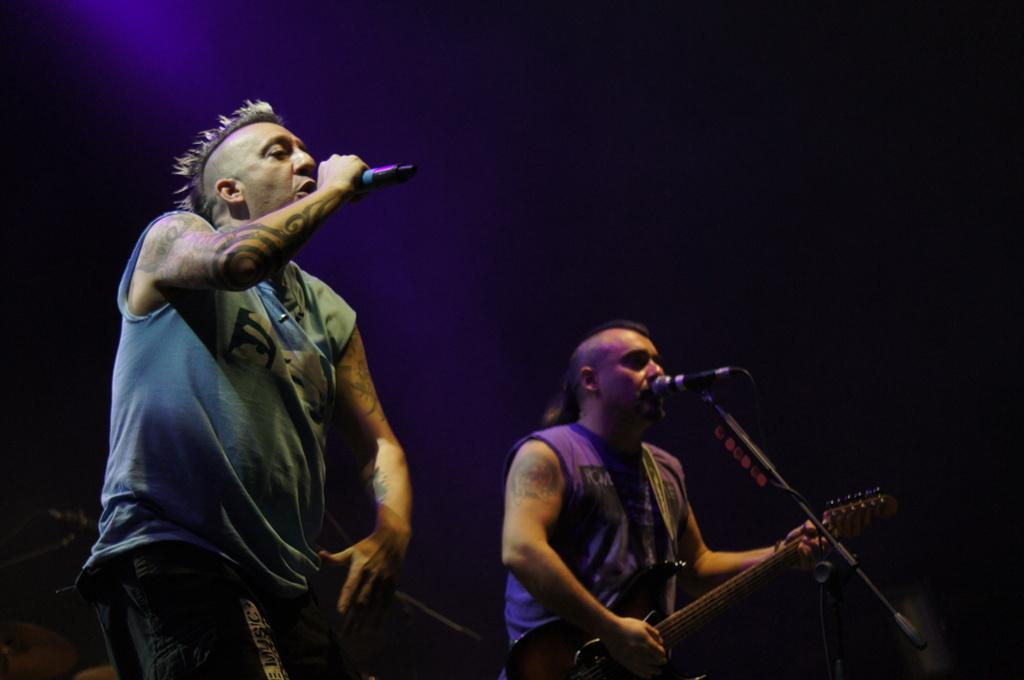What is the man in the image doing? The man is standing and singing into a microphone. Is there anyone else in the image? Yes, there is another man standing and playing a guitar near the microphone. What is the second man doing in the image? The second man is playing a guitar near the microphone. What type of creature can be seen walking towards the north in the image? There is no creature present in the image, and the direction of movement is not mentioned. 